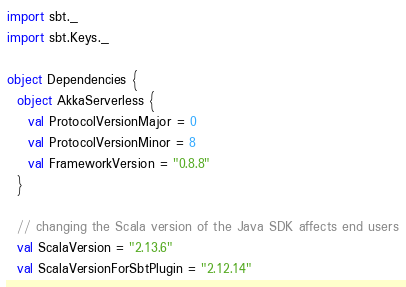<code> <loc_0><loc_0><loc_500><loc_500><_Scala_>import sbt._
import sbt.Keys._

object Dependencies {
  object AkkaServerless {
    val ProtocolVersionMajor = 0
    val ProtocolVersionMinor = 8
    val FrameworkVersion = "0.8.8"
  }

  // changing the Scala version of the Java SDK affects end users
  val ScalaVersion = "2.13.6"
  val ScalaVersionForSbtPlugin = "2.12.14"</code> 